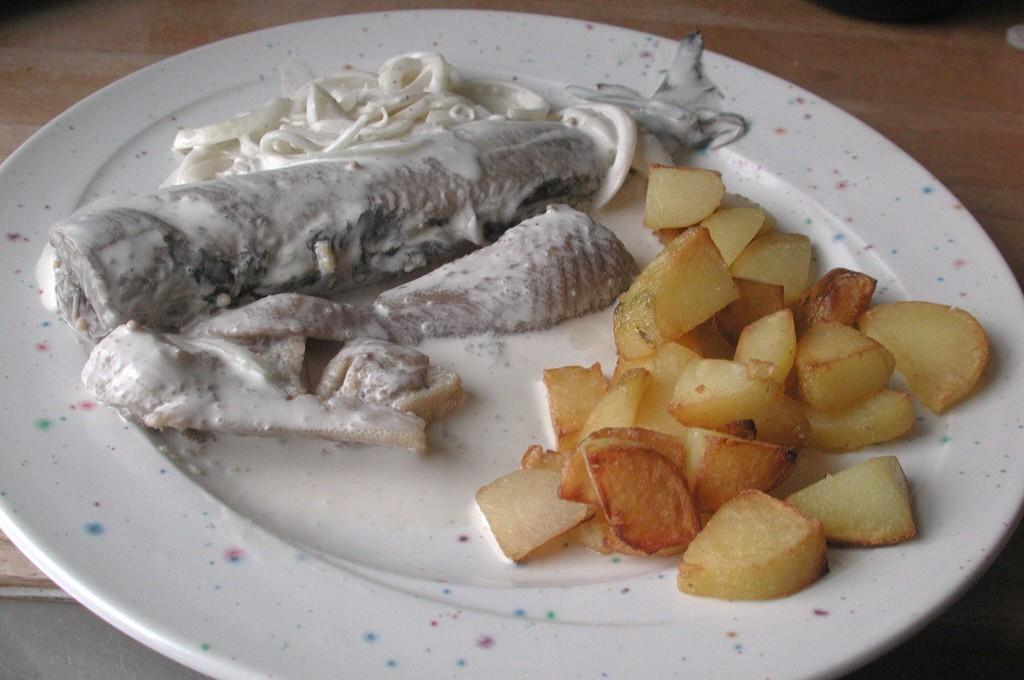Where was the image taken? The image is taken indoors. What piece of furniture is present in the image? There is a table in the image. What is placed on the table? There is a plate on the table. What can be found on the plate? There is a food item on the plate. What type of railway can be seen in the image? There is no railway present in the image. Is the queen visible in the image? There is no queen present in the image. 